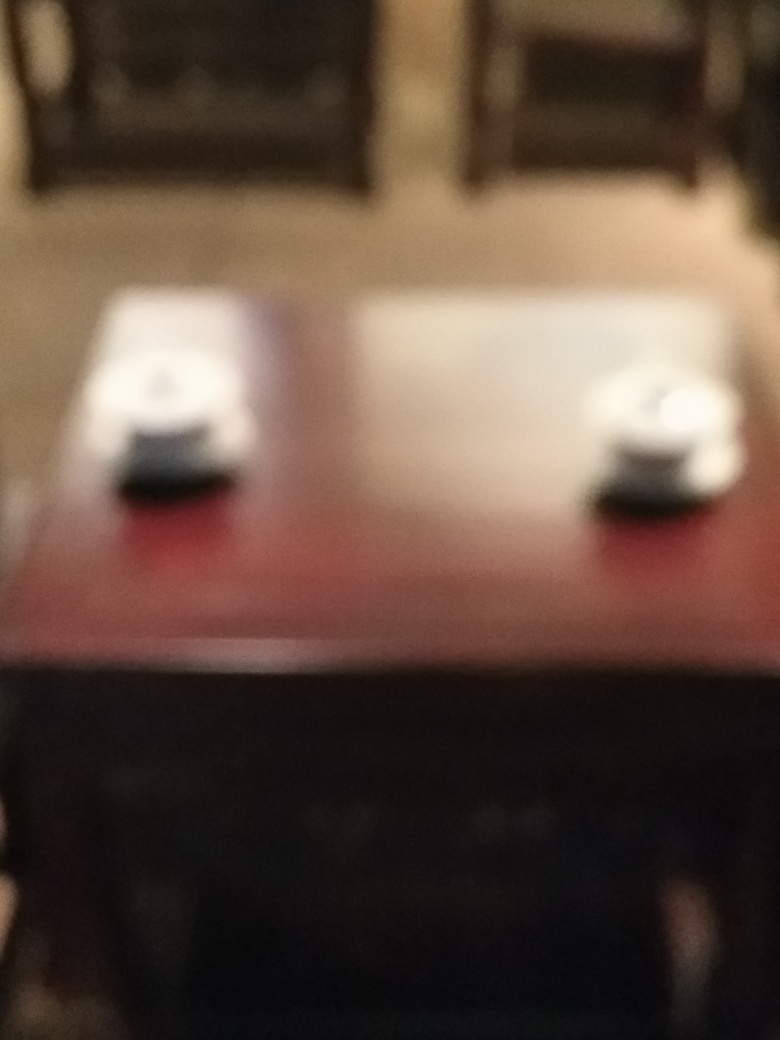Can you describe the setting of this image? While the specific details are unclear due to the focus issue, it seems to be an interior setting, possibly a room with a table in the foreground on which there are two items—perhaps cups or small objects—resting on it. 